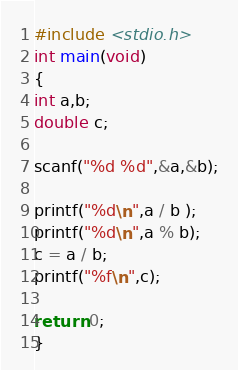Convert code to text. <code><loc_0><loc_0><loc_500><loc_500><_C_>#include <stdio.h>
int main(void)
{
int a,b;
double c;

scanf("%d %d",&a,&b);

printf("%d\n",a / b );
printf("%d\n",a % b);
c = a / b;
printf("%f\n",c);

return 0;
}</code> 